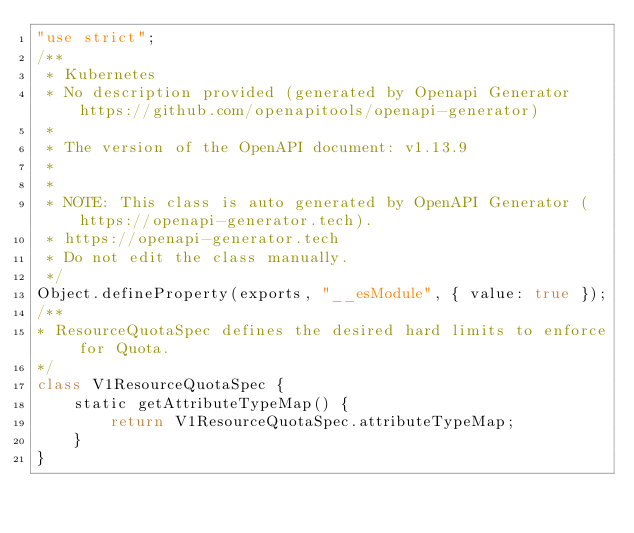<code> <loc_0><loc_0><loc_500><loc_500><_JavaScript_>"use strict";
/**
 * Kubernetes
 * No description provided (generated by Openapi Generator https://github.com/openapitools/openapi-generator)
 *
 * The version of the OpenAPI document: v1.13.9
 *
 *
 * NOTE: This class is auto generated by OpenAPI Generator (https://openapi-generator.tech).
 * https://openapi-generator.tech
 * Do not edit the class manually.
 */
Object.defineProperty(exports, "__esModule", { value: true });
/**
* ResourceQuotaSpec defines the desired hard limits to enforce for Quota.
*/
class V1ResourceQuotaSpec {
    static getAttributeTypeMap() {
        return V1ResourceQuotaSpec.attributeTypeMap;
    }
}</code> 